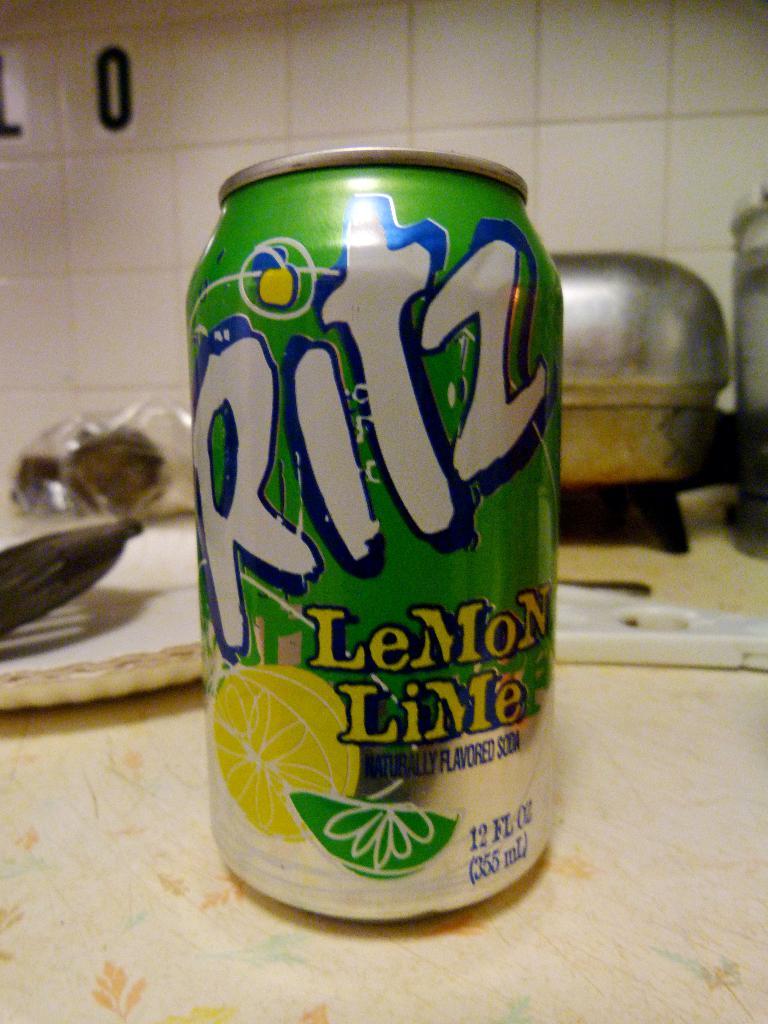What brand of soda is this?
Offer a very short reply. Ritz. 